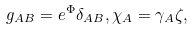<formula> <loc_0><loc_0><loc_500><loc_500>g _ { A B } = e ^ { \Phi } \delta _ { A B } , \chi _ { A } = \gamma _ { A } \zeta ,</formula> 